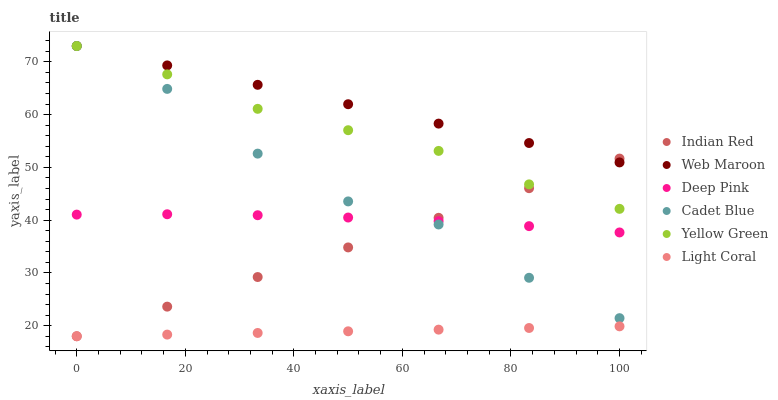Does Light Coral have the minimum area under the curve?
Answer yes or no. Yes. Does Web Maroon have the maximum area under the curve?
Answer yes or no. Yes. Does Yellow Green have the minimum area under the curve?
Answer yes or no. No. Does Yellow Green have the maximum area under the curve?
Answer yes or no. No. Is Light Coral the smoothest?
Answer yes or no. Yes. Is Cadet Blue the roughest?
Answer yes or no. Yes. Is Yellow Green the smoothest?
Answer yes or no. No. Is Yellow Green the roughest?
Answer yes or no. No. Does Light Coral have the lowest value?
Answer yes or no. Yes. Does Yellow Green have the lowest value?
Answer yes or no. No. Does Web Maroon have the highest value?
Answer yes or no. Yes. Does Light Coral have the highest value?
Answer yes or no. No. Is Light Coral less than Deep Pink?
Answer yes or no. Yes. Is Web Maroon greater than Light Coral?
Answer yes or no. Yes. Does Web Maroon intersect Yellow Green?
Answer yes or no. Yes. Is Web Maroon less than Yellow Green?
Answer yes or no. No. Is Web Maroon greater than Yellow Green?
Answer yes or no. No. Does Light Coral intersect Deep Pink?
Answer yes or no. No. 